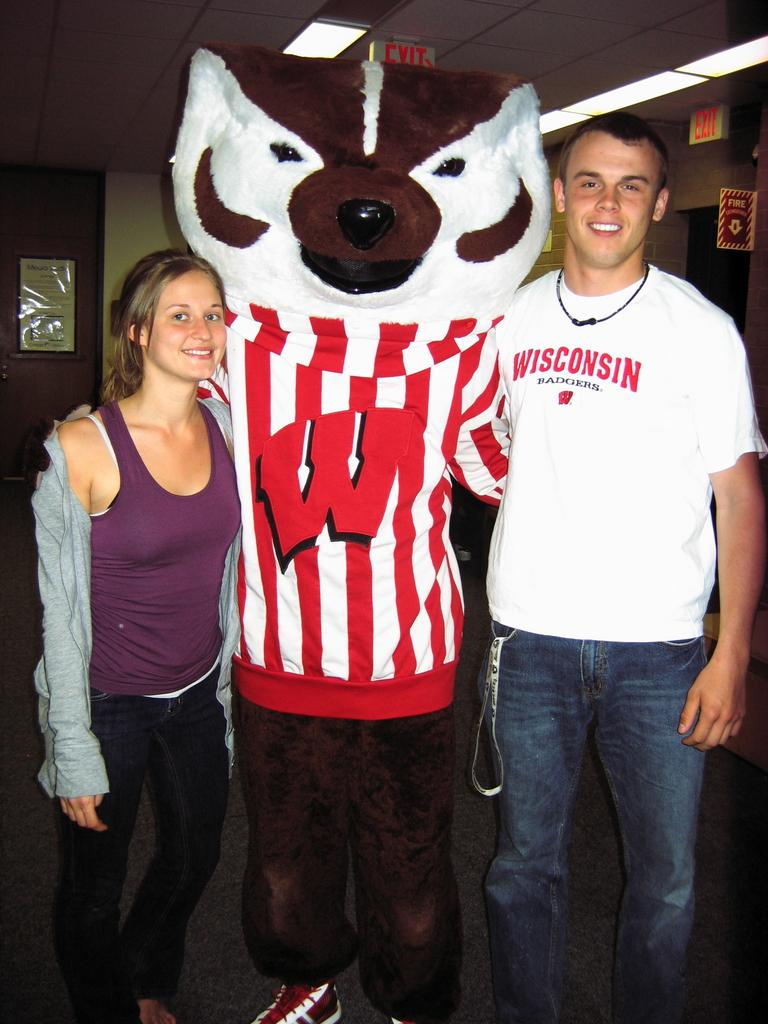<image>
Render a clear and concise summary of the photo. A young girl and boy standing with their school mascot who wears a large W on his shirt. 